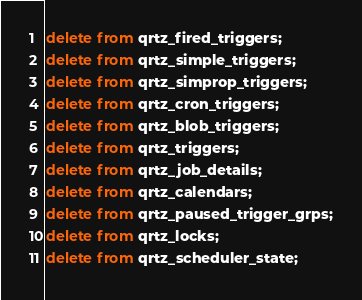<code> <loc_0><loc_0><loc_500><loc_500><_SQL_>delete from qrtz_fired_triggers;delete from qrtz_simple_triggers;delete from qrtz_simprop_triggers;delete from qrtz_cron_triggers;delete from qrtz_blob_triggers;delete from qrtz_triggers;delete from qrtz_job_details;delete from qrtz_calendars;delete from qrtz_paused_trigger_grps;delete from qrtz_locks;delete from qrtz_scheduler_state;</code> 